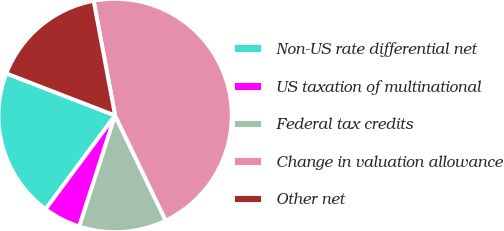Convert chart to OTSL. <chart><loc_0><loc_0><loc_500><loc_500><pie_chart><fcel>Non-US rate differential net<fcel>US taxation of multinational<fcel>Federal tax credits<fcel>Change in valuation allowance<fcel>Other net<nl><fcel>20.72%<fcel>5.19%<fcel>12.12%<fcel>45.8%<fcel>16.18%<nl></chart> 